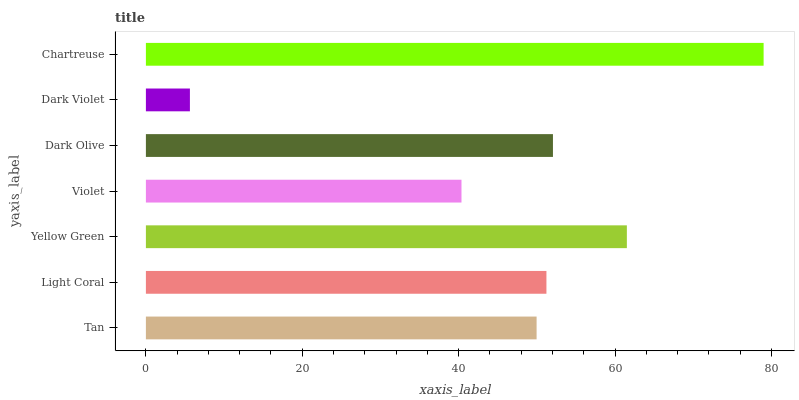Is Dark Violet the minimum?
Answer yes or no. Yes. Is Chartreuse the maximum?
Answer yes or no. Yes. Is Light Coral the minimum?
Answer yes or no. No. Is Light Coral the maximum?
Answer yes or no. No. Is Light Coral greater than Tan?
Answer yes or no. Yes. Is Tan less than Light Coral?
Answer yes or no. Yes. Is Tan greater than Light Coral?
Answer yes or no. No. Is Light Coral less than Tan?
Answer yes or no. No. Is Light Coral the high median?
Answer yes or no. Yes. Is Light Coral the low median?
Answer yes or no. Yes. Is Dark Olive the high median?
Answer yes or no. No. Is Dark Olive the low median?
Answer yes or no. No. 